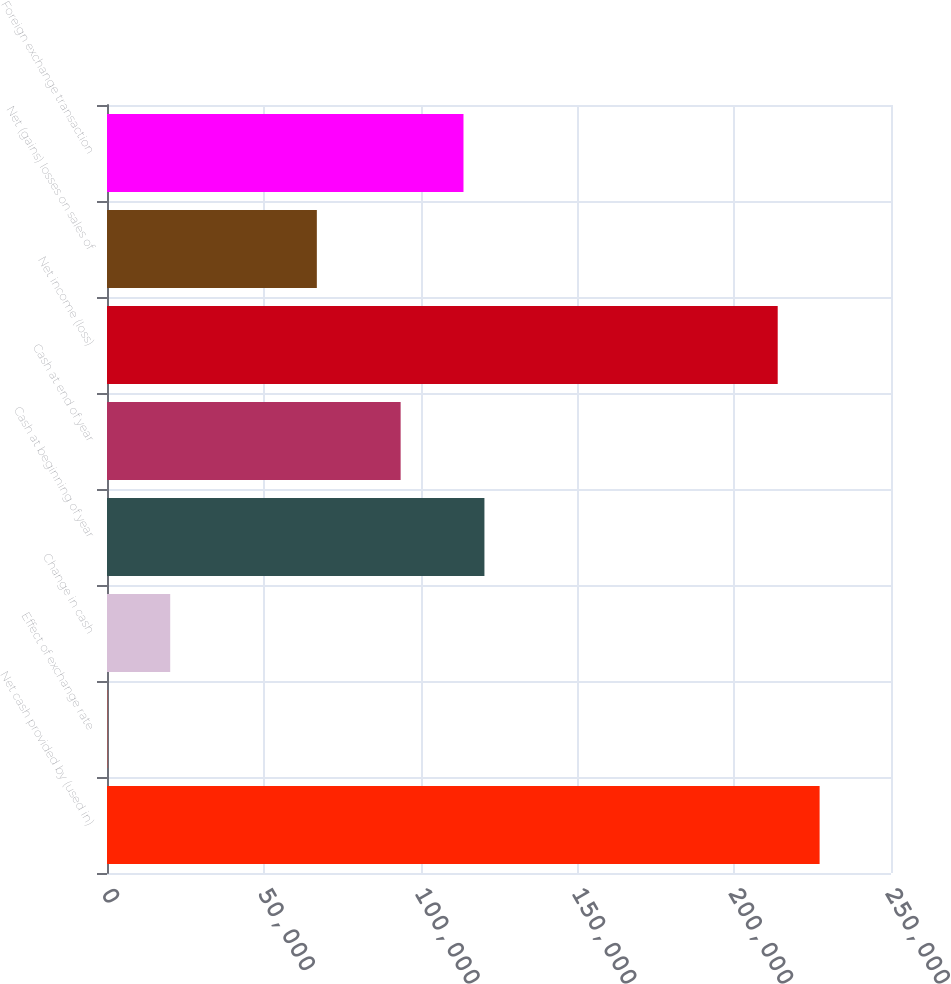Convert chart to OTSL. <chart><loc_0><loc_0><loc_500><loc_500><bar_chart><fcel>Net cash provided by (used in)<fcel>Effect of exchange rate<fcel>Change in cash<fcel>Cash at beginning of year<fcel>Cash at end of year<fcel>Net income (loss)<fcel>Net (gains) losses on sales of<fcel>Foreign exchange transaction<nl><fcel>227234<fcel>114<fcel>20154<fcel>120354<fcel>93634<fcel>213874<fcel>66914<fcel>113674<nl></chart> 